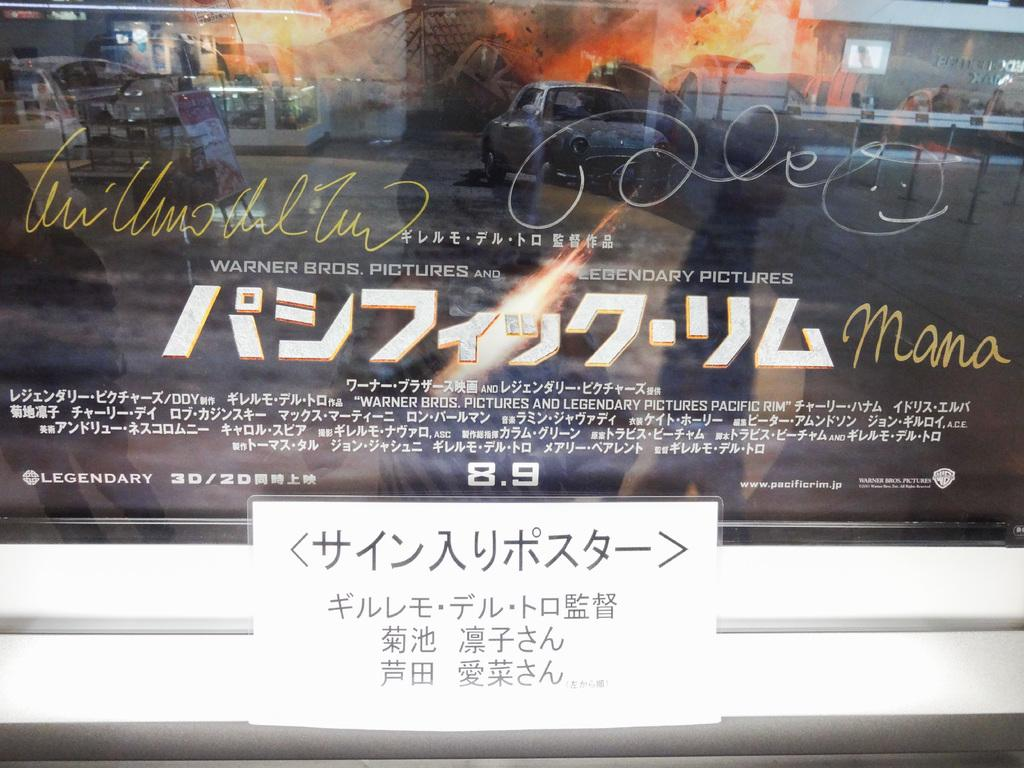Provide a one-sentence caption for the provided image. A foreign movie poster with the numbers 8.9 in the bottom middle. 